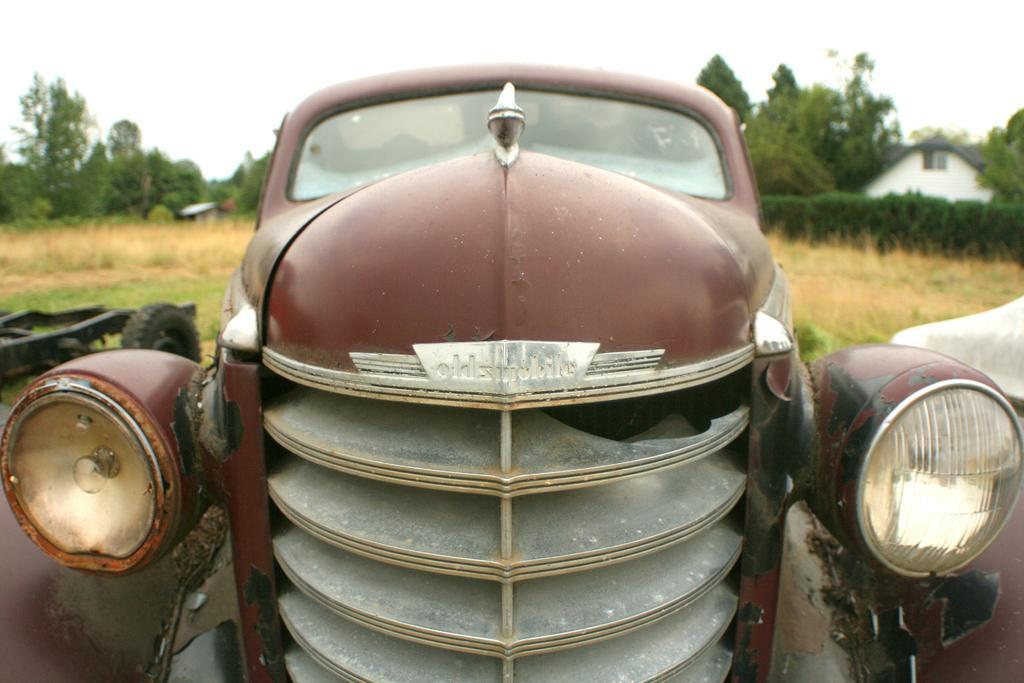What is the main subject of the image? There is a vehicle in the image. What specific feature can be seen on the vehicle? The vehicle has headlights. What type of natural environment is visible in the background of the image? There is grass, plants, trees, and a house in the background of the image. What part of the natural environment is not visible in the image? The sky is visible in the background of the image. What type of harmony is being played by the team of actors in the image? There is no team of actors or any musical instruments present in the image, so it is not possible to determine if any harmony is being played. 